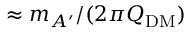Convert formula to latex. <formula><loc_0><loc_0><loc_500><loc_500>\approx m _ { A ^ { \prime } } / ( 2 \pi Q _ { D M } )</formula> 